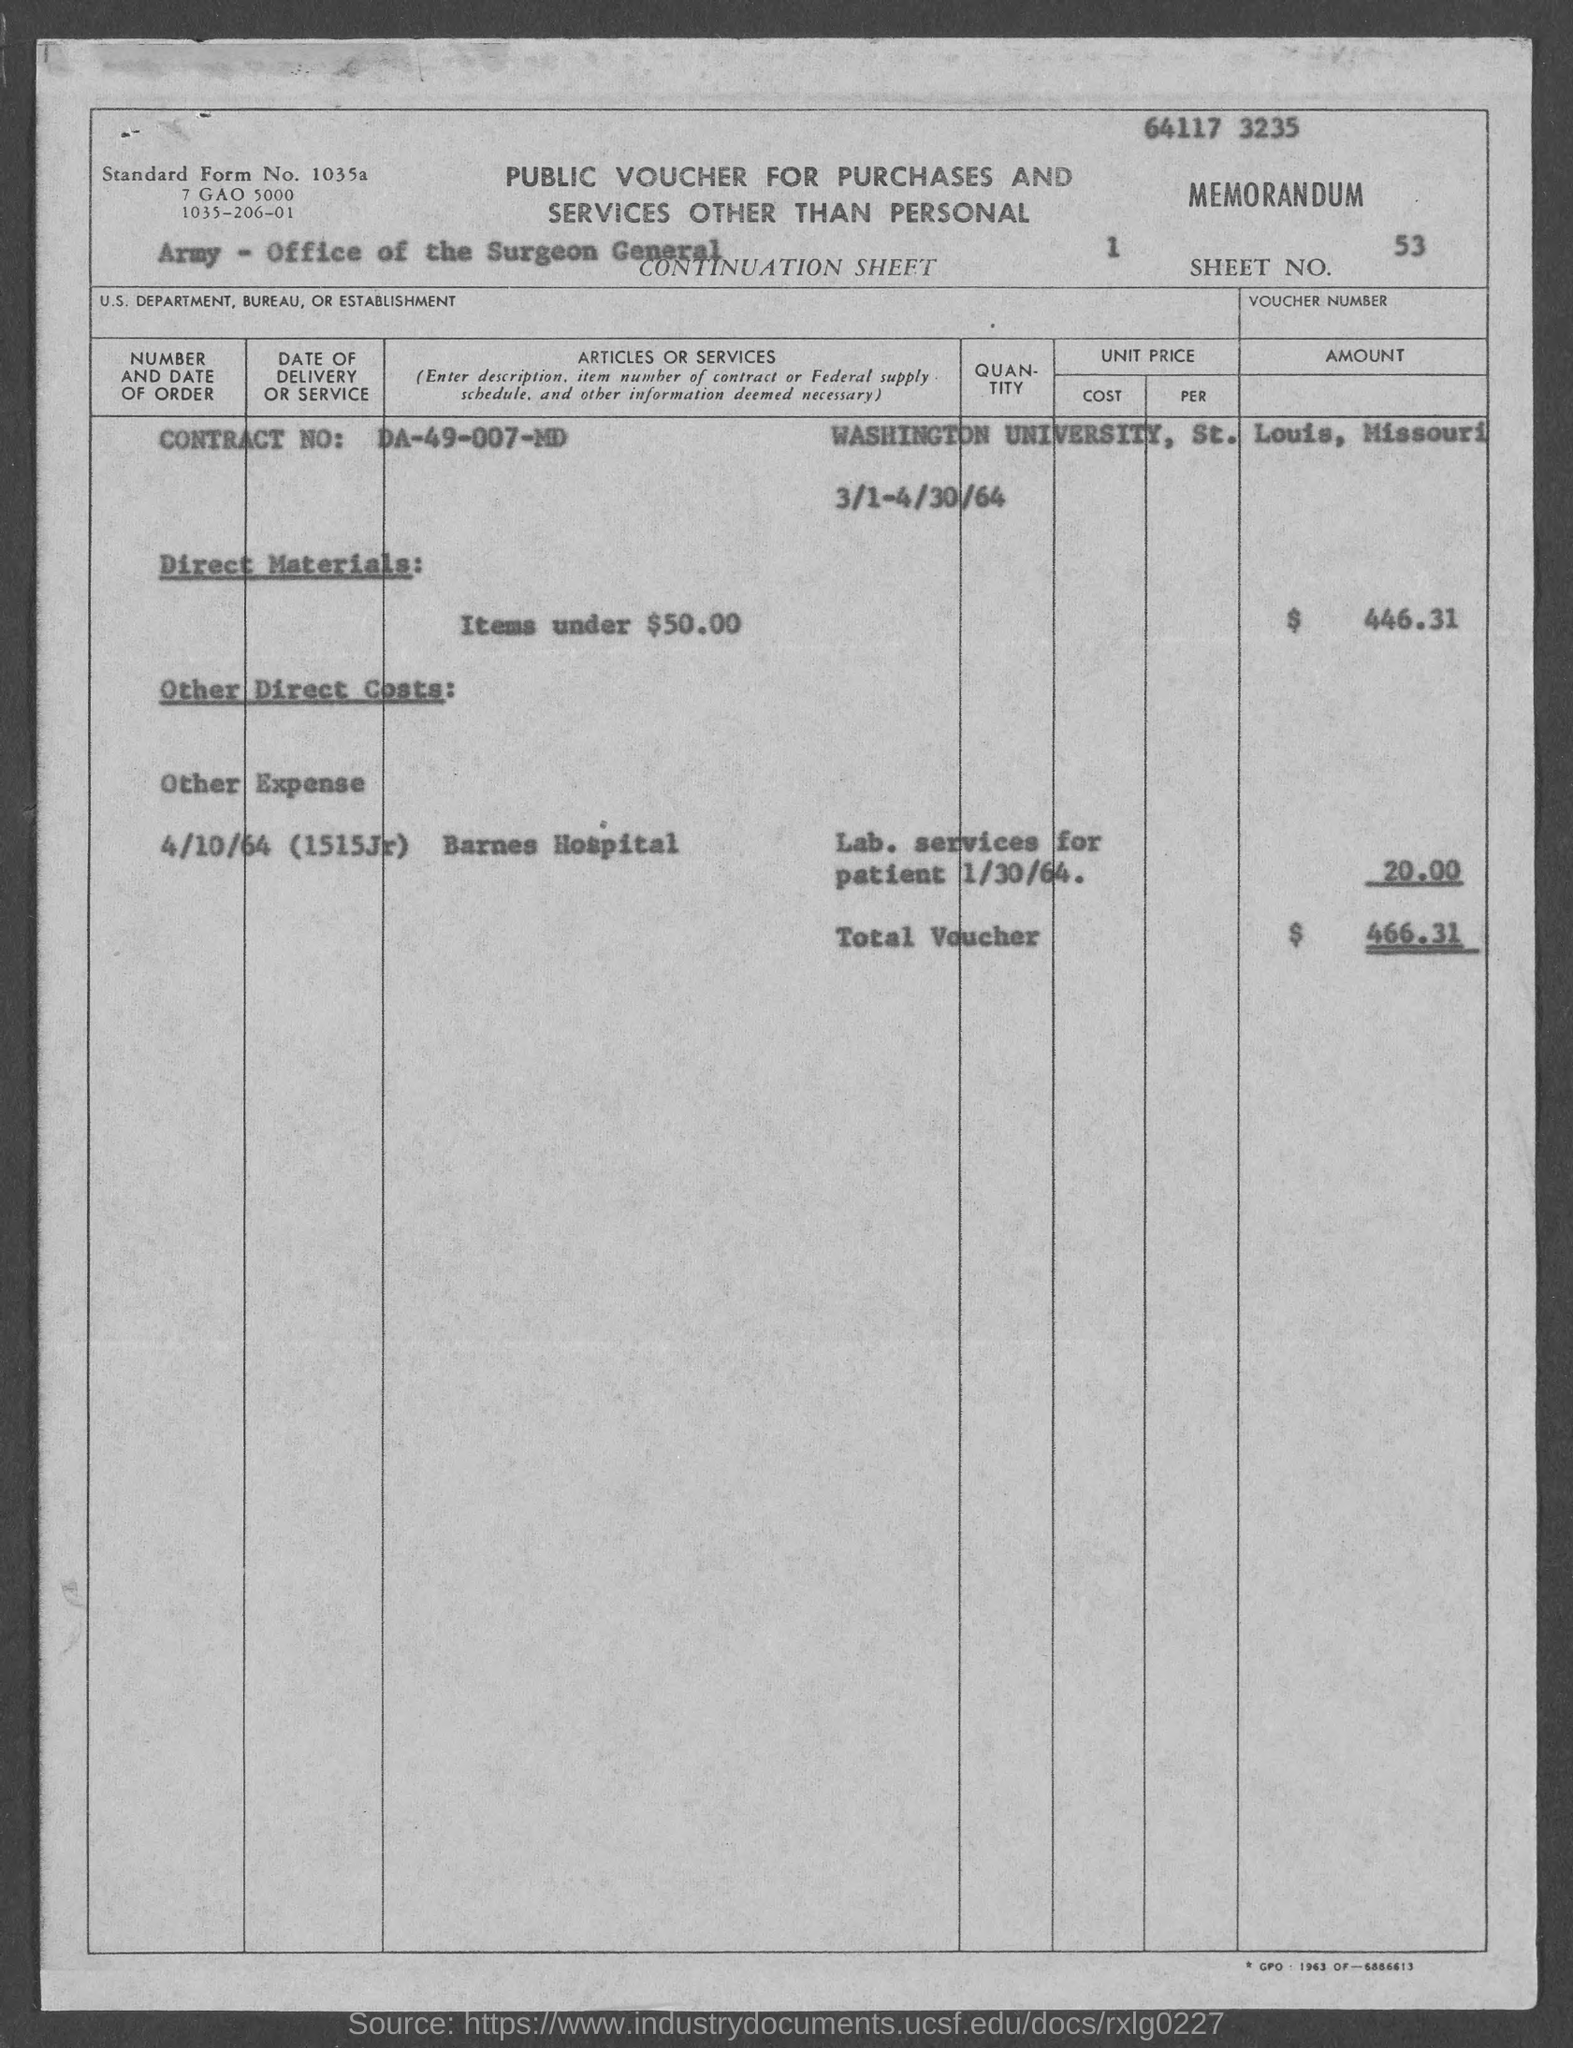What is the sheet no. mentioned in the given page ?
Make the answer very short. 53. What is the contract no. mentioned in the given form ?
Keep it short and to the point. Da-49-007-md. What is the name of the university mentioned in the given form ?
Your answer should be compact. Washington university. What is the amount for direct materials as mentioned in the given form ?
Your answer should be very brief. $ 446.31. What is the amount of other expense as mentioned in the given form ?
Your answer should be very brief. 20. 